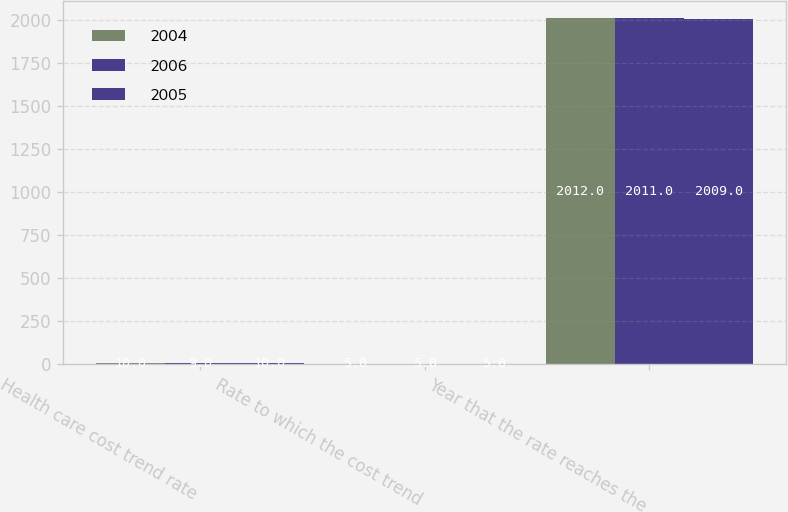Convert chart. <chart><loc_0><loc_0><loc_500><loc_500><stacked_bar_chart><ecel><fcel>Health care cost trend rate<fcel>Rate to which the cost trend<fcel>Year that the rate reaches the<nl><fcel>2004<fcel>10<fcel>5<fcel>2012<nl><fcel>2006<fcel>9<fcel>5<fcel>2011<nl><fcel>2005<fcel>10<fcel>5<fcel>2009<nl></chart> 